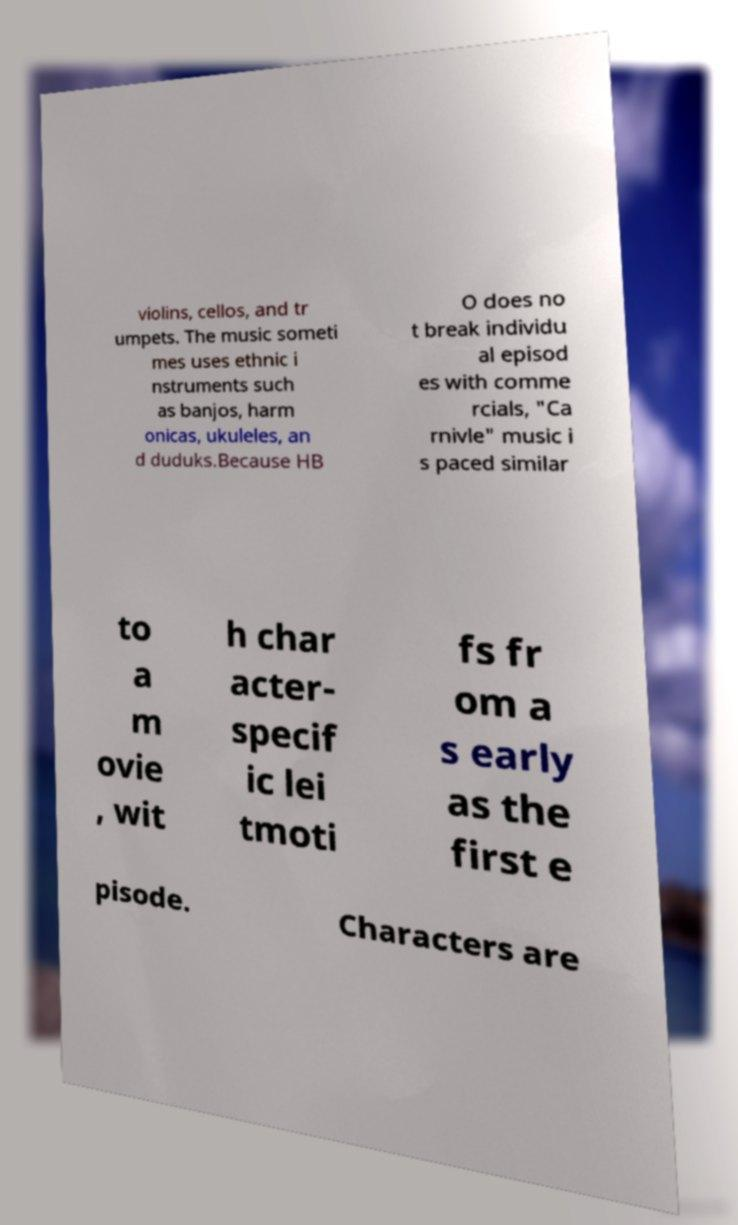Can you accurately transcribe the text from the provided image for me? violins, cellos, and tr umpets. The music someti mes uses ethnic i nstruments such as banjos, harm onicas, ukuleles, an d duduks.Because HB O does no t break individu al episod es with comme rcials, "Ca rnivle" music i s paced similar to a m ovie , wit h char acter- specif ic lei tmoti fs fr om a s early as the first e pisode. Characters are 